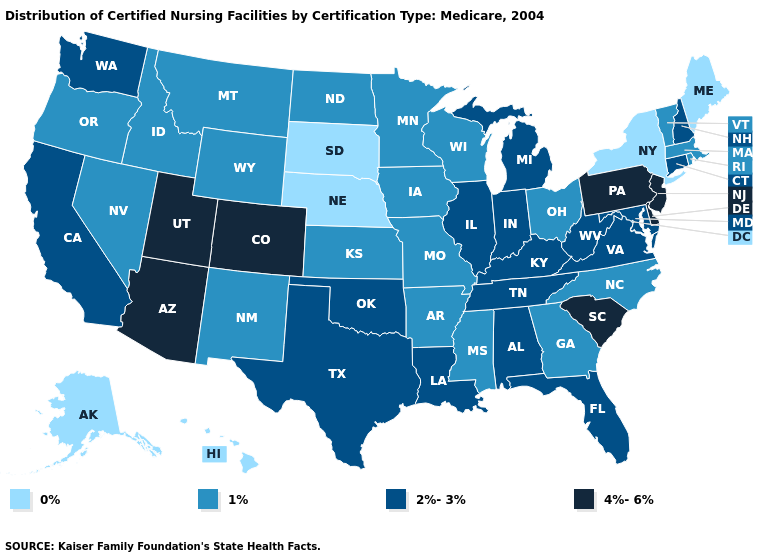What is the value of Alabama?
Write a very short answer. 2%-3%. Which states have the highest value in the USA?
Keep it brief. Arizona, Colorado, Delaware, New Jersey, Pennsylvania, South Carolina, Utah. What is the value of West Virginia?
Short answer required. 2%-3%. What is the value of Pennsylvania?
Give a very brief answer. 4%-6%. Among the states that border Utah , which have the highest value?
Answer briefly. Arizona, Colorado. What is the value of New Hampshire?
Short answer required. 2%-3%. Is the legend a continuous bar?
Answer briefly. No. What is the value of Georgia?
Write a very short answer. 1%. How many symbols are there in the legend?
Quick response, please. 4. Among the states that border South Dakota , which have the lowest value?
Quick response, please. Nebraska. Does Missouri have the lowest value in the MidWest?
Be succinct. No. Name the states that have a value in the range 4%-6%?
Answer briefly. Arizona, Colorado, Delaware, New Jersey, Pennsylvania, South Carolina, Utah. Name the states that have a value in the range 4%-6%?
Short answer required. Arizona, Colorado, Delaware, New Jersey, Pennsylvania, South Carolina, Utah. Name the states that have a value in the range 0%?
Answer briefly. Alaska, Hawaii, Maine, Nebraska, New York, South Dakota. Among the states that border New York , which have the lowest value?
Give a very brief answer. Massachusetts, Vermont. 